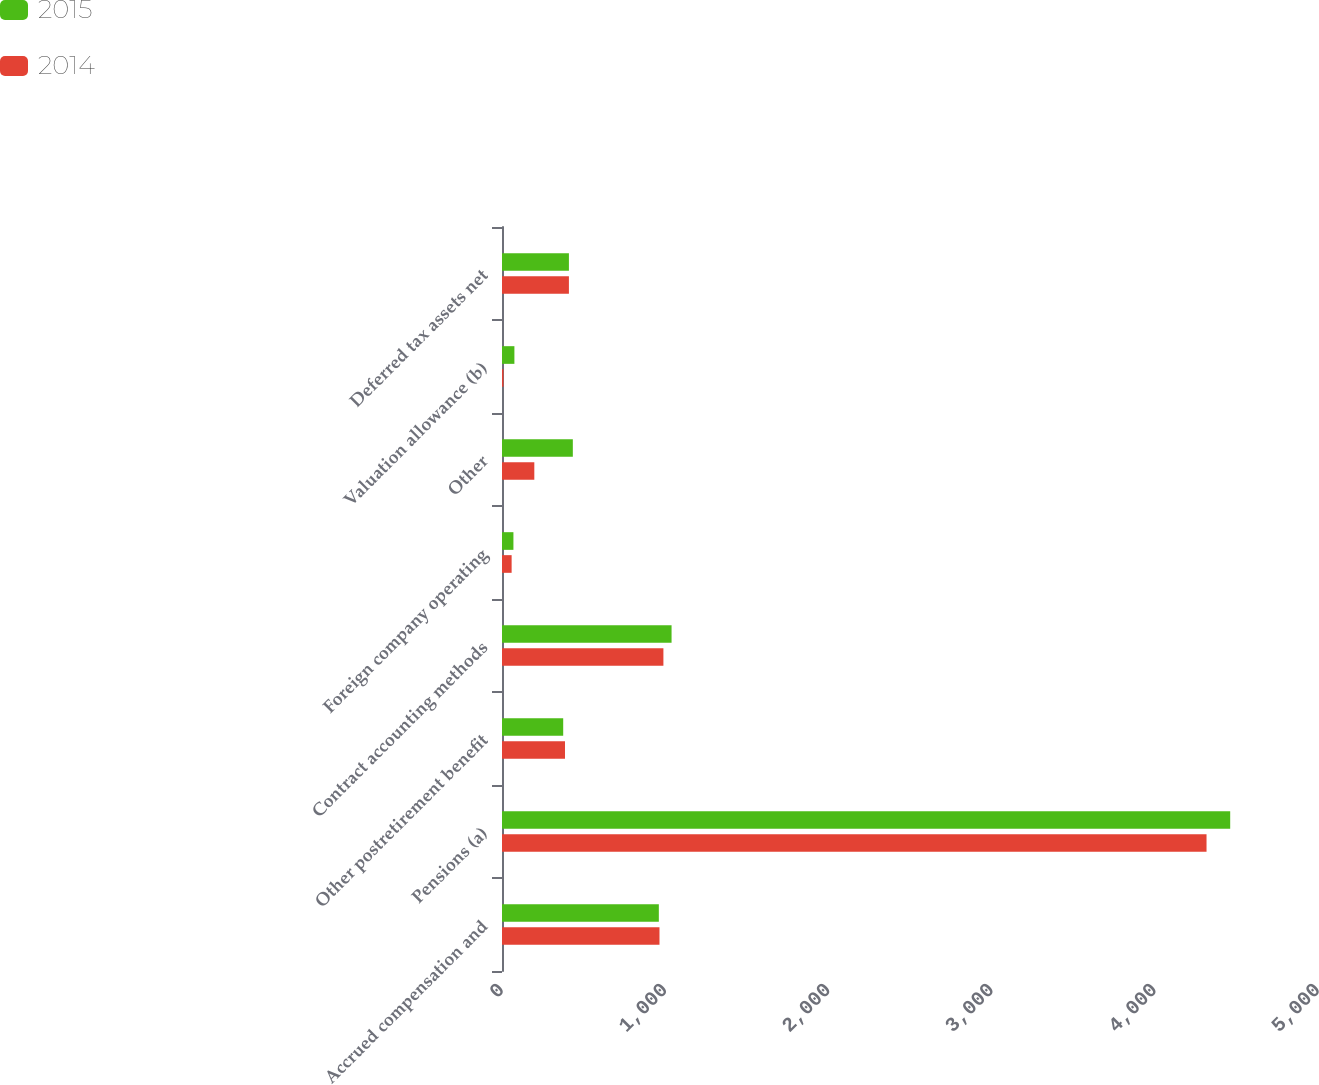Convert chart. <chart><loc_0><loc_0><loc_500><loc_500><stacked_bar_chart><ecel><fcel>Accrued compensation and<fcel>Pensions (a)<fcel>Other postretirement benefit<fcel>Contract accounting methods<fcel>Foreign company operating<fcel>Other<fcel>Valuation allowance (b)<fcel>Deferred tax assets net<nl><fcel>2015<fcel>961<fcel>4462<fcel>375<fcel>1039<fcel>70<fcel>434<fcel>76<fcel>410<nl><fcel>2014<fcel>965<fcel>4317<fcel>386<fcel>989<fcel>59<fcel>198<fcel>9<fcel>410<nl></chart> 